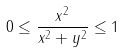Convert formula to latex. <formula><loc_0><loc_0><loc_500><loc_500>0 \leq \frac { x ^ { 2 } } { x ^ { 2 } + y ^ { 2 } } \leq 1</formula> 